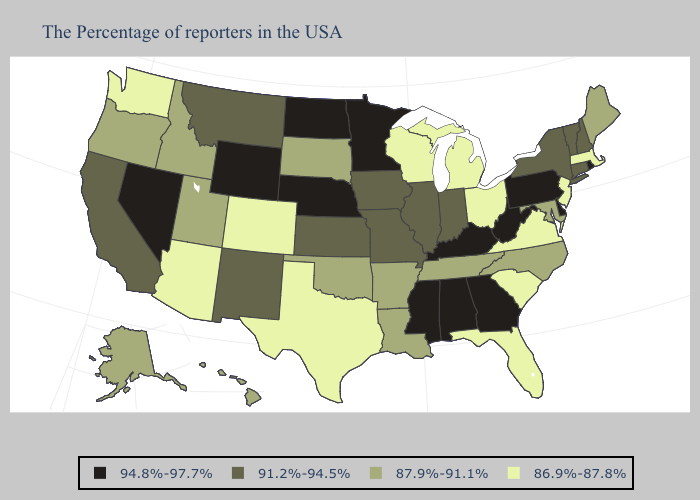What is the lowest value in states that border New Jersey?
Quick response, please. 91.2%-94.5%. Does the map have missing data?
Answer briefly. No. Does North Dakota have the lowest value in the USA?
Be succinct. No. Name the states that have a value in the range 91.2%-94.5%?
Keep it brief. New Hampshire, Vermont, Connecticut, New York, Indiana, Illinois, Missouri, Iowa, Kansas, New Mexico, Montana, California. What is the lowest value in the MidWest?
Answer briefly. 86.9%-87.8%. Name the states that have a value in the range 87.9%-91.1%?
Keep it brief. Maine, Maryland, North Carolina, Tennessee, Louisiana, Arkansas, Oklahoma, South Dakota, Utah, Idaho, Oregon, Alaska, Hawaii. Name the states that have a value in the range 94.8%-97.7%?
Short answer required. Rhode Island, Delaware, Pennsylvania, West Virginia, Georgia, Kentucky, Alabama, Mississippi, Minnesota, Nebraska, North Dakota, Wyoming, Nevada. What is the lowest value in states that border New Jersey?
Write a very short answer. 91.2%-94.5%. What is the value of Minnesota?
Quick response, please. 94.8%-97.7%. Among the states that border Maryland , which have the lowest value?
Quick response, please. Virginia. Does Oklahoma have the same value as Alaska?
Be succinct. Yes. What is the value of Oregon?
Keep it brief. 87.9%-91.1%. What is the value of Mississippi?
Give a very brief answer. 94.8%-97.7%. What is the highest value in the USA?
Quick response, please. 94.8%-97.7%. Name the states that have a value in the range 94.8%-97.7%?
Be succinct. Rhode Island, Delaware, Pennsylvania, West Virginia, Georgia, Kentucky, Alabama, Mississippi, Minnesota, Nebraska, North Dakota, Wyoming, Nevada. 